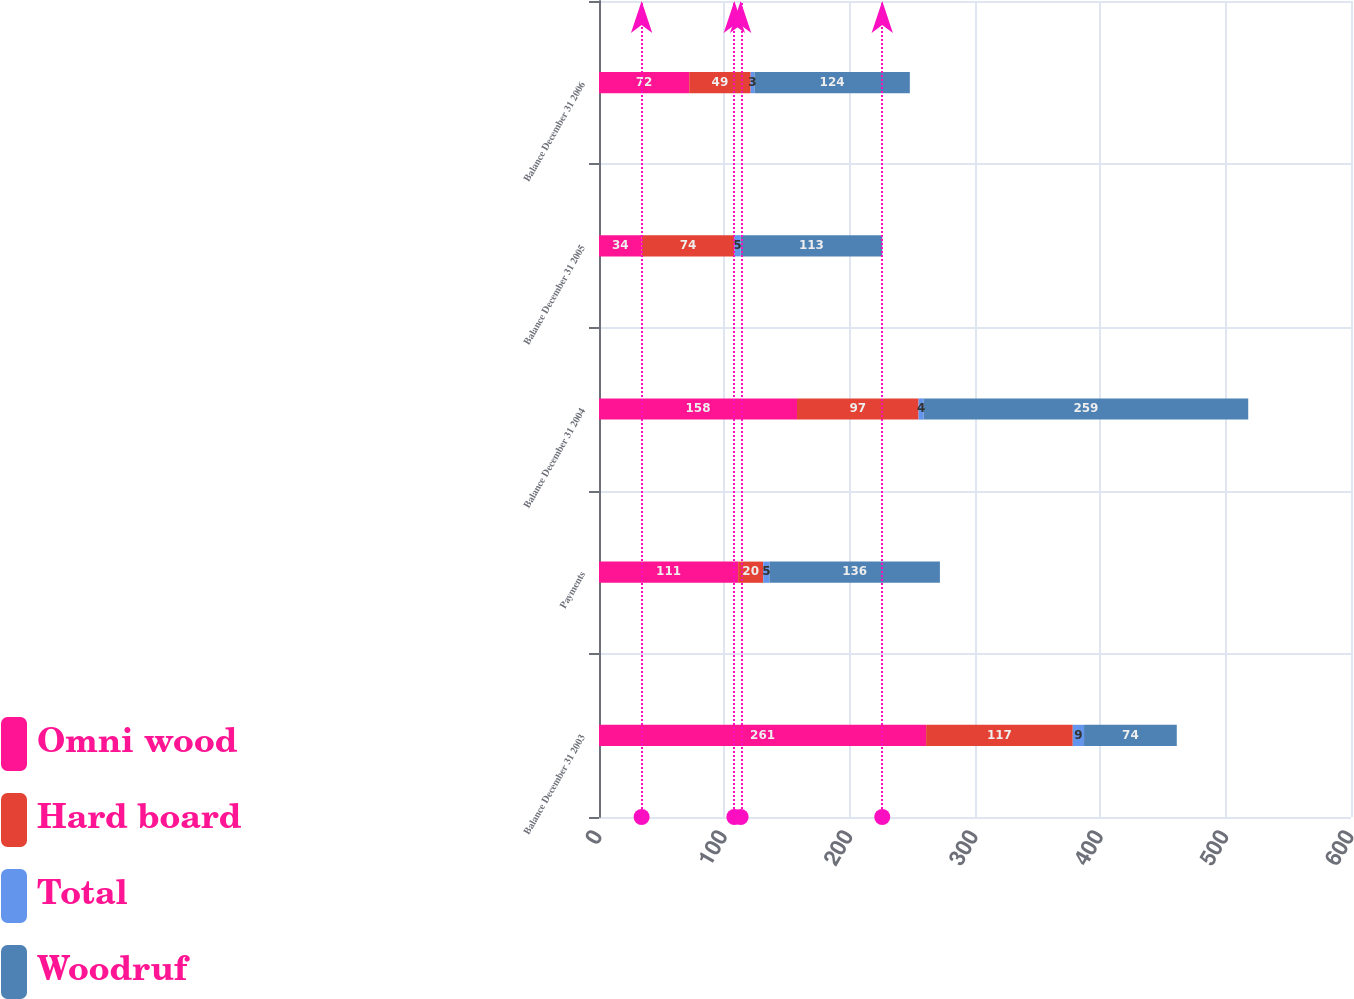<chart> <loc_0><loc_0><loc_500><loc_500><stacked_bar_chart><ecel><fcel>Balance December 31 2003<fcel>Payments<fcel>Balance December 31 2004<fcel>Balance December 31 2005<fcel>Balance December 31 2006<nl><fcel>Omni wood<fcel>261<fcel>111<fcel>158<fcel>34<fcel>72<nl><fcel>Hard board<fcel>117<fcel>20<fcel>97<fcel>74<fcel>49<nl><fcel>Total<fcel>9<fcel>5<fcel>4<fcel>5<fcel>3<nl><fcel>Woodruf<fcel>74<fcel>136<fcel>259<fcel>113<fcel>124<nl></chart> 